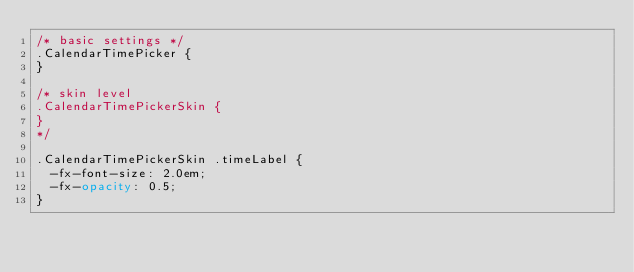<code> <loc_0><loc_0><loc_500><loc_500><_CSS_>/* basic settings */
.CalendarTimePicker { 
}

/* skin level 
.CalendarTimePickerSkin { 
}
*/

.CalendarTimePickerSkin .timeLabel { 
	-fx-font-size: 2.0em;
	-fx-opacity: 0.5;
}

</code> 